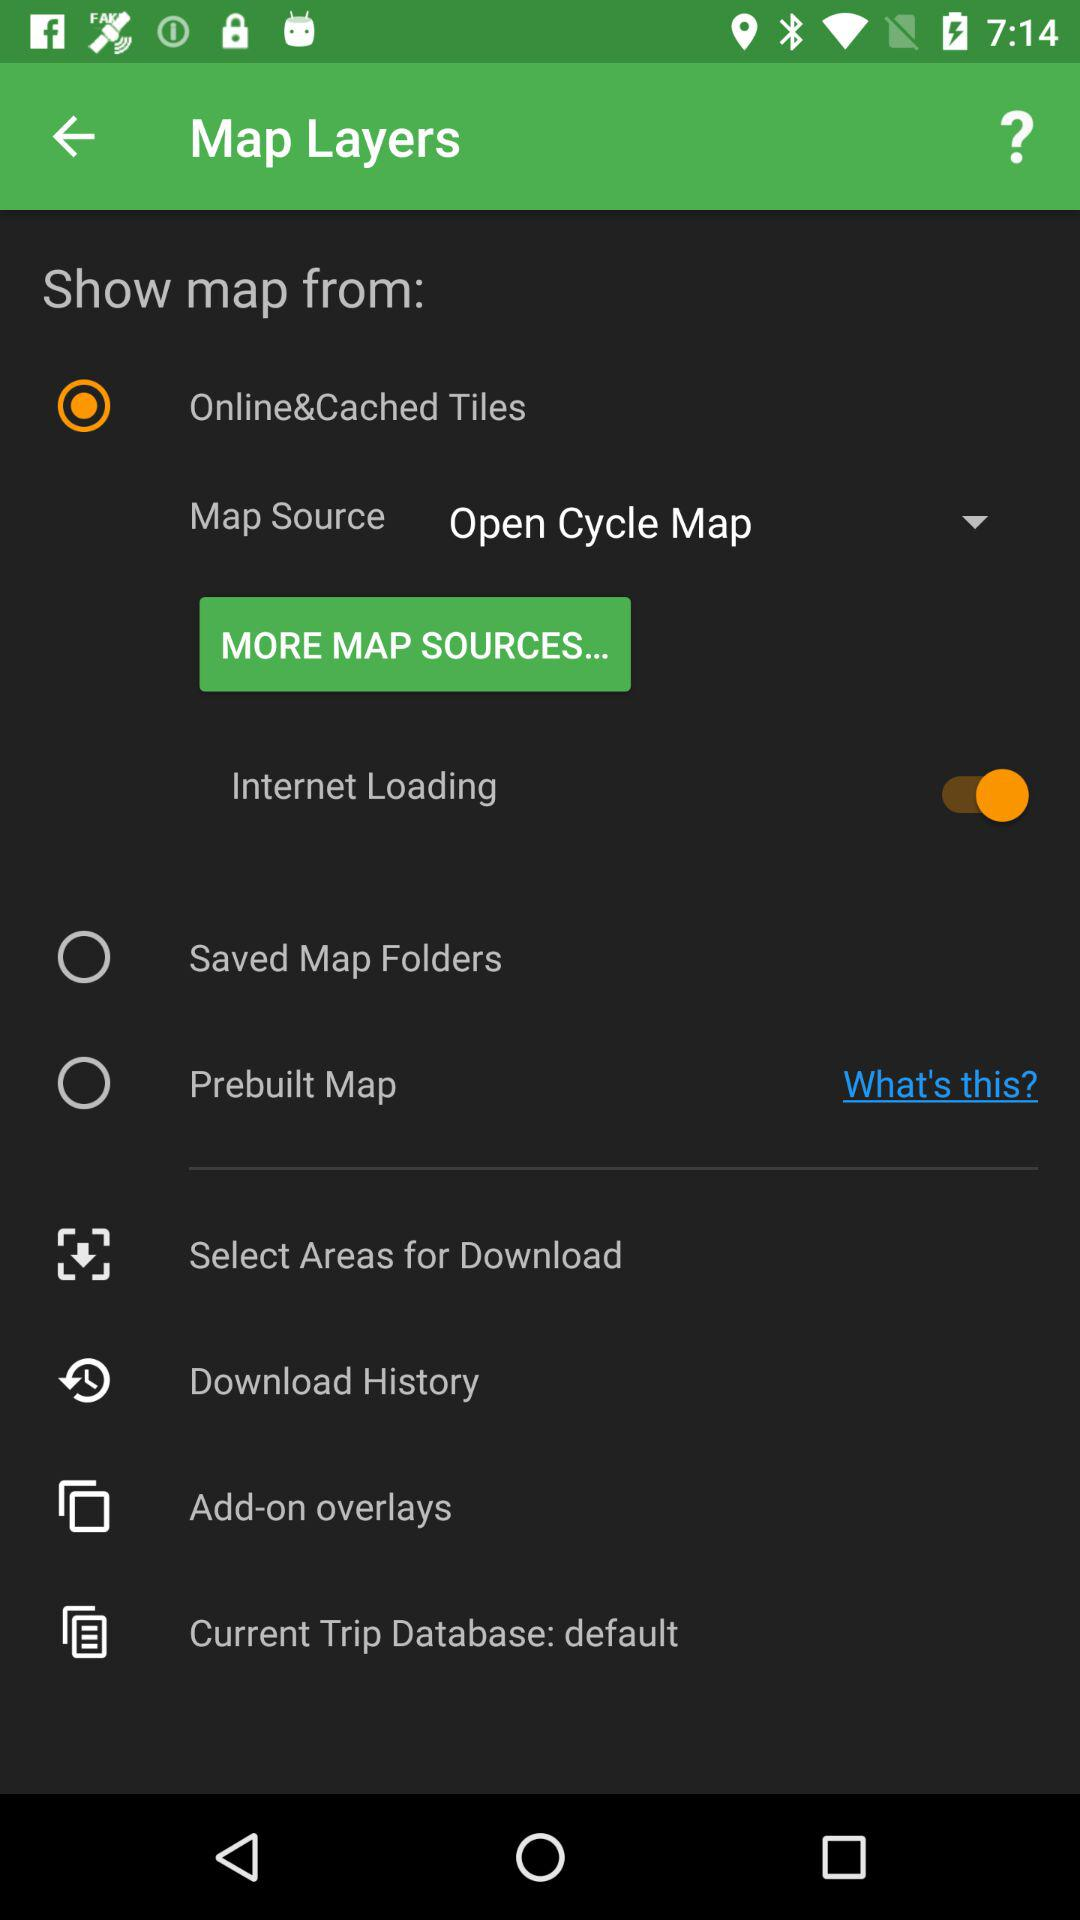What is the selected map source? The selected map source is "Open Cycle Map". 